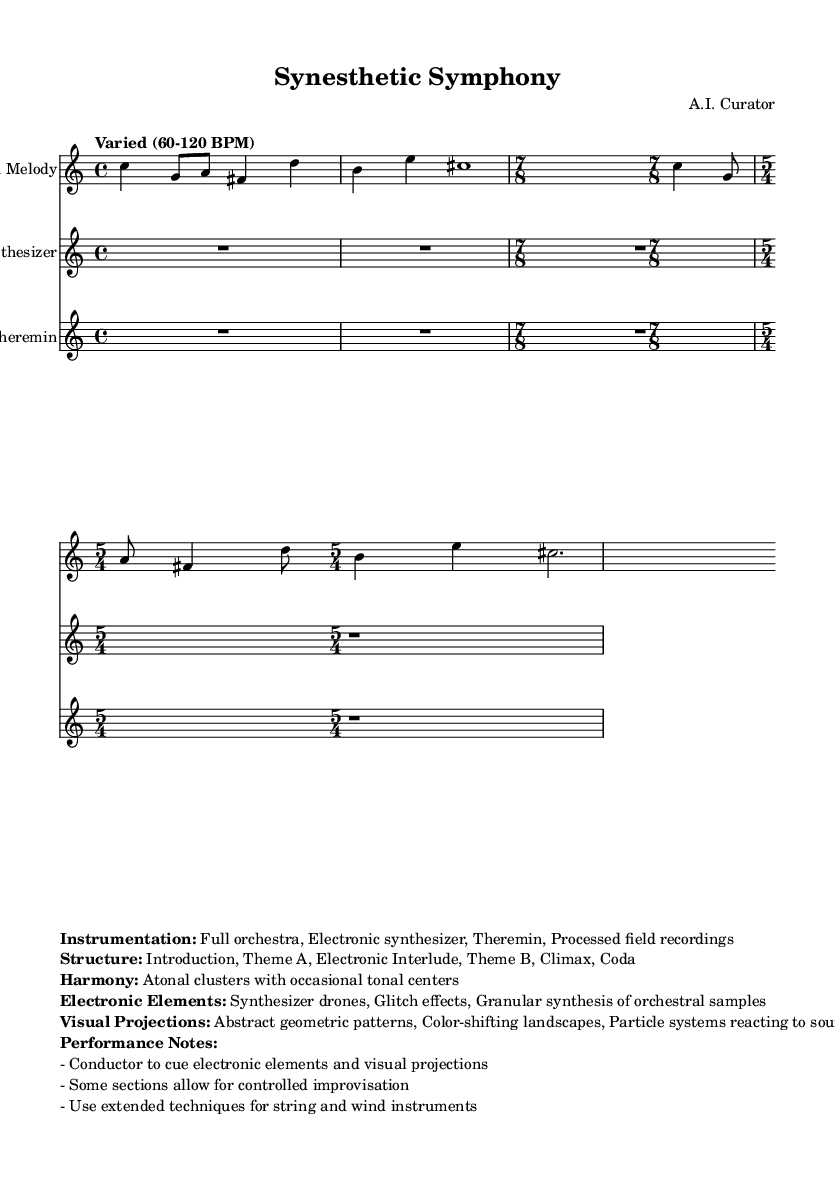What is the time signature of the main melody? The main melody begins with a time signature of 4/4, then changes to 7/8, and finally to 5/4. The first time signature is indicated at the beginning of the melody section.
Answer: 4/4, 7/8, 5/4 What electronic elements are present in this piece? The piece incorporates a synthesizer, a theremin, and uses processed field recordings. The markup clearly lists these electronic elements in the information section under "Electronic Elements."
Answer: Synthesizer, Theremin, Processed field recordings How many sections does the piece have? The structure is outlined in the markup, which lists six distinct sections: Introduction, Theme A, Electronic Interlude, Theme B, Climax, and Coda. Each of these sections represents a part of the overall structure of the piece.
Answer: 6 What type of harmony is used in this composition? The markup specifies "Atonal clusters with occasional tonal centers." This describes the harmonic structure of the piece, showing it's primarily atonal but does include some tonal moments.
Answer: Atonal clusters What is the tempo range indicated for the piece? The tempo marking in the global settings is stated as "Varied (60-120 BPM)," which means the tempo can fluctuate within this range during the performance. This indicates the piece allows for flexibility in pace.
Answer: Varied (60-120 BPM) What performance notes are mentioned for the conductor? The markup provides specific performance notes, stating "Conductor to cue electronic elements and visual projections." This indicates the conductor has a role in coordinating these elements during the performance.
Answer: Cue electronic elements and visual projections 